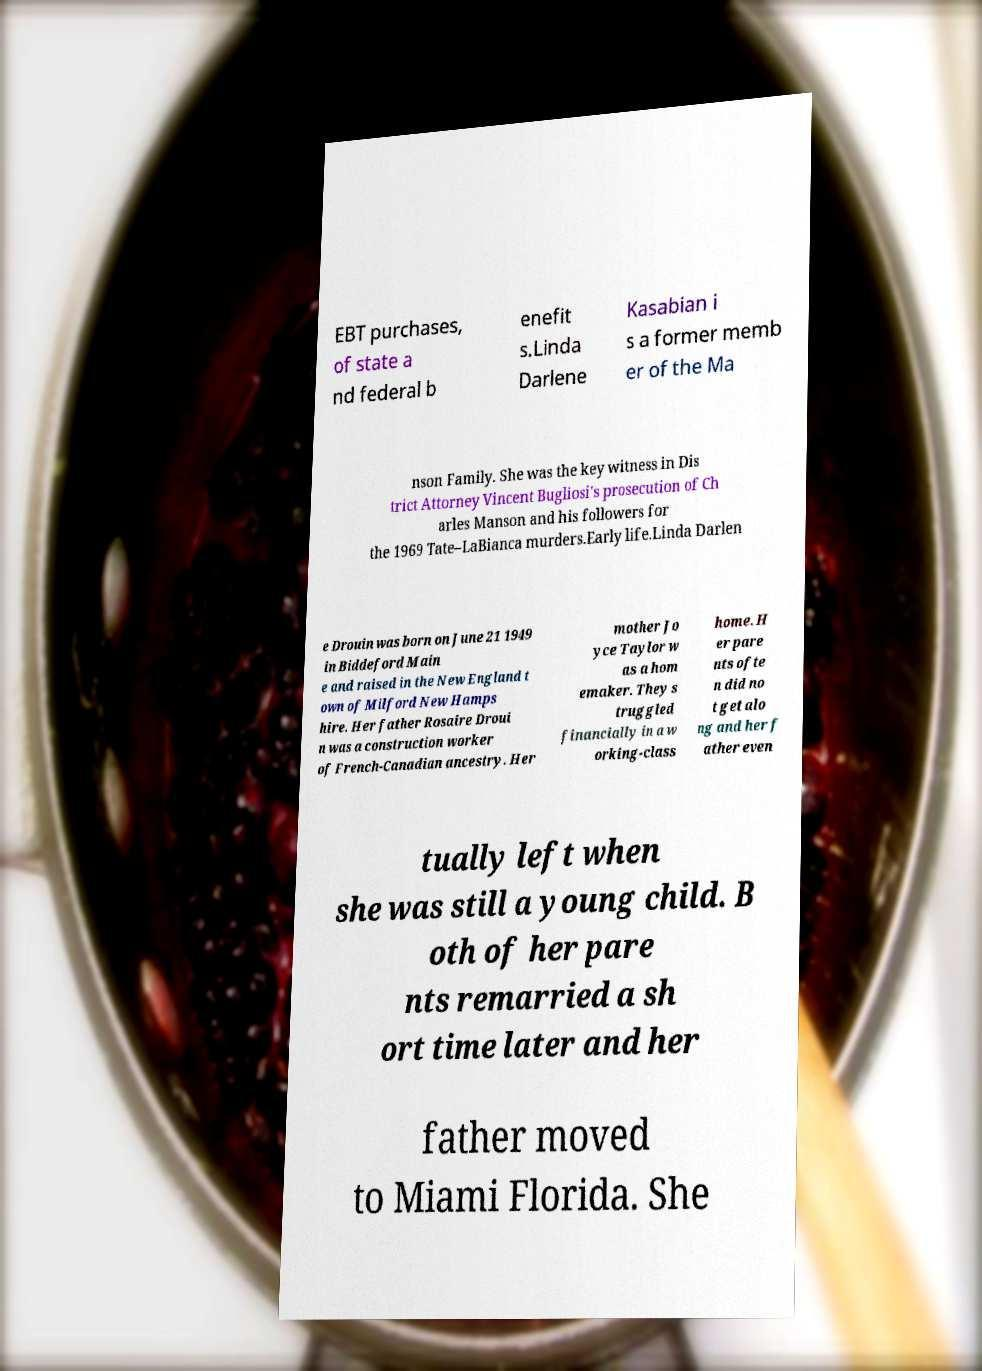Can you accurately transcribe the text from the provided image for me? EBT purchases, of state a nd federal b enefit s.Linda Darlene Kasabian i s a former memb er of the Ma nson Family. She was the key witness in Dis trict Attorney Vincent Bugliosi's prosecution of Ch arles Manson and his followers for the 1969 Tate–LaBianca murders.Early life.Linda Darlen e Drouin was born on June 21 1949 in Biddeford Main e and raised in the New England t own of Milford New Hamps hire. Her father Rosaire Droui n was a construction worker of French-Canadian ancestry. Her mother Jo yce Taylor w as a hom emaker. They s truggled financially in a w orking-class home. H er pare nts ofte n did no t get alo ng and her f ather even tually left when she was still a young child. B oth of her pare nts remarried a sh ort time later and her father moved to Miami Florida. She 